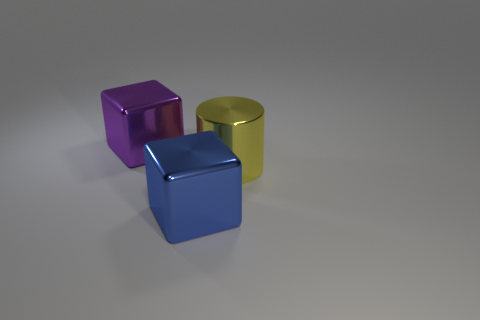Add 3 big yellow cylinders. How many objects exist? 6 Subtract all cylinders. How many objects are left? 2 Subtract 1 yellow cylinders. How many objects are left? 2 Subtract all blue metallic cubes. Subtract all yellow shiny objects. How many objects are left? 1 Add 3 large cylinders. How many large cylinders are left? 4 Add 3 big blue shiny objects. How many big blue shiny objects exist? 4 